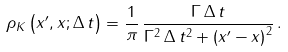Convert formula to latex. <formula><loc_0><loc_0><loc_500><loc_500>\rho _ { K } \left ( x ^ { \prime } , x ; \Delta \, t \right ) = \frac { 1 } { \pi } \, \frac { \Gamma \, \Delta \, t } { \Gamma ^ { 2 } \, \Delta \, t ^ { 2 } + \left ( x ^ { \prime } - x \right ) ^ { 2 } } \, .</formula> 